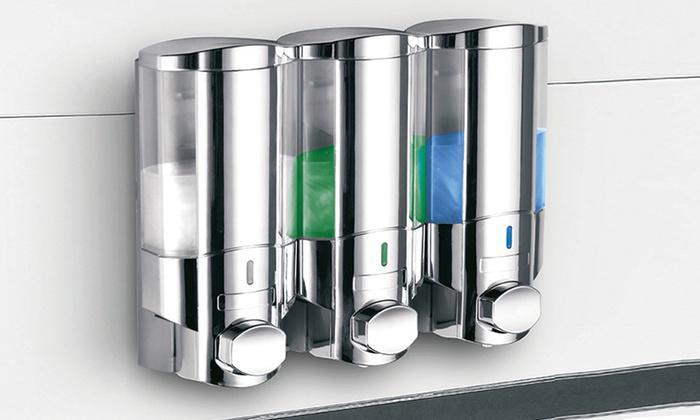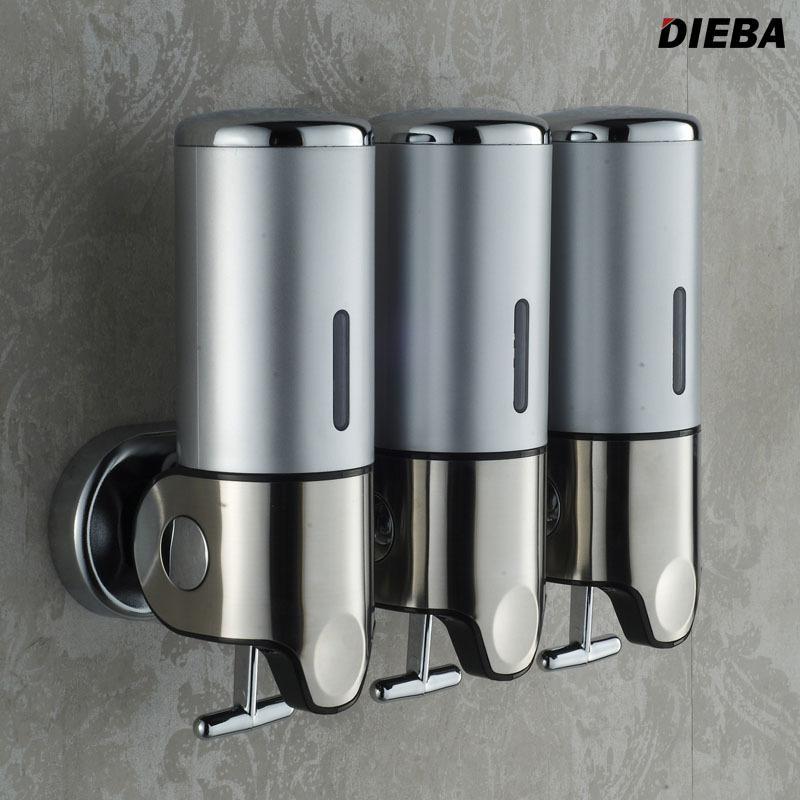The first image is the image on the left, the second image is the image on the right. For the images shown, is this caption "At least one image contains three dispensers which are all not transparent." true? Answer yes or no. Yes. The first image is the image on the left, the second image is the image on the right. Evaluate the accuracy of this statement regarding the images: "There are three dispensers in which the top half is fully silver with only one line of an open window to see liquid.". Is it true? Answer yes or no. Yes. 